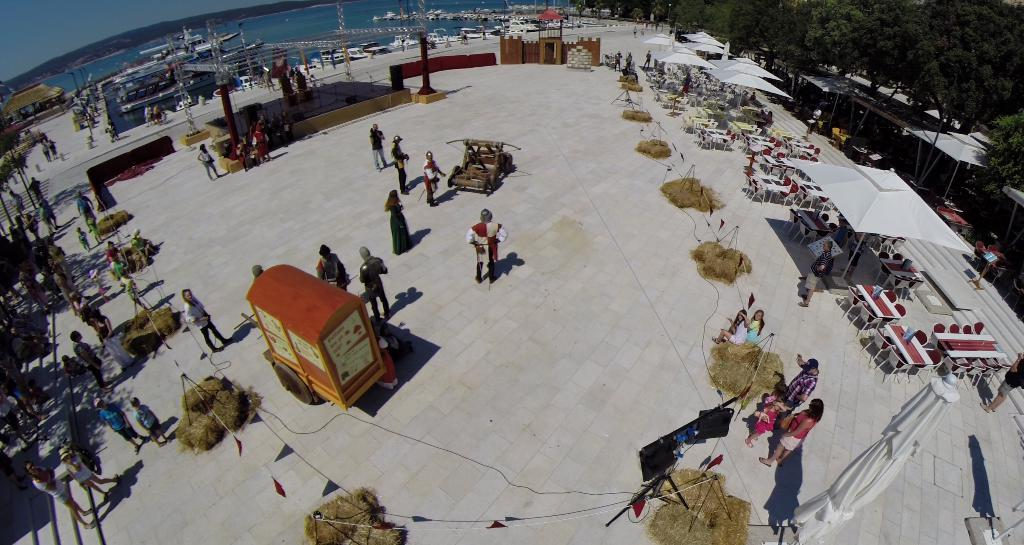What type of furniture is present in the image? There are tables and chairs in the image. What type of structures can be seen in the image? There are shelters in the image. Who or what is present in the image? There are people in the image. What mode of transportation is visible in the image? There is a vehicle in the image. What type of natural environment is visible in the image? There is grass visible in the image. What type of man-made structures can be seen in the image? There are wires and metal objects in the image. What type of vegetation is visible in the image? There are trees in the image. What type of liquid is visible in the image? There is water visible in the image. What type of letters can be seen in the image? There are no letters visible in the image. What type of creature can be seen interacting with the people in the image? There is no creature visible in the image. 